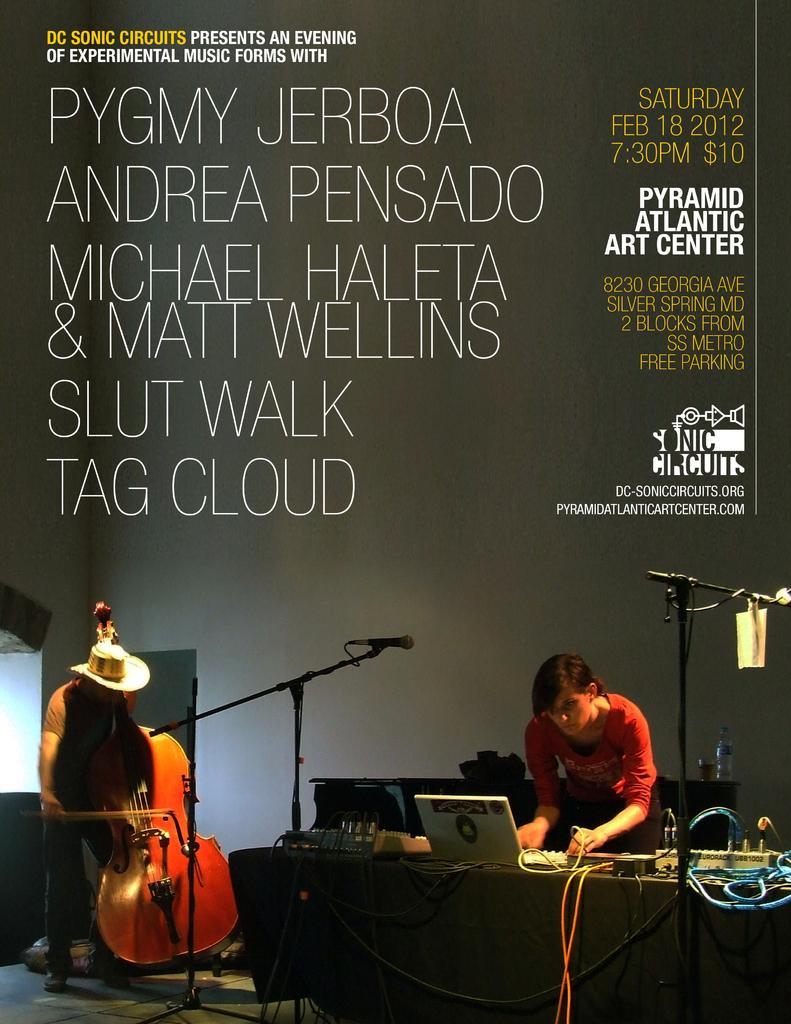Can you describe this image briefly? In this picture I can see a poster with some text and I can see couple of them standing and I can see a woman working on the laptop and I can see couple of microphones and a violin and I can see few electronic devices on the table. 